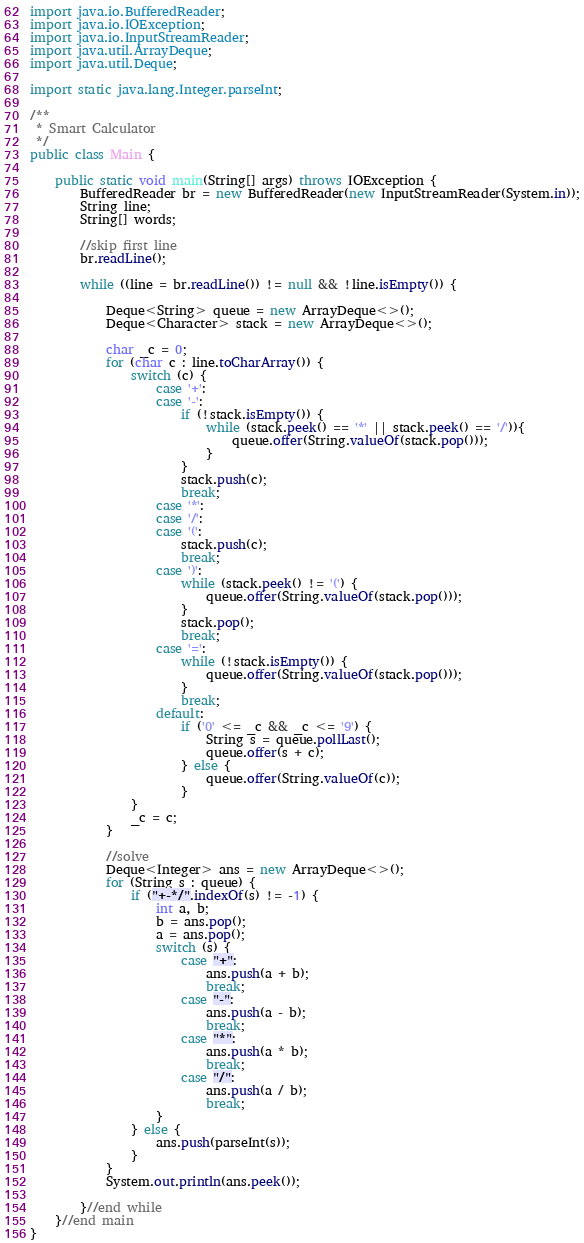<code> <loc_0><loc_0><loc_500><loc_500><_Java_>import java.io.BufferedReader;
import java.io.IOException;
import java.io.InputStreamReader;
import java.util.ArrayDeque;
import java.util.Deque;

import static java.lang.Integer.parseInt;

/**
 * Smart Calculator
 */
public class Main {

	public static void main(String[] args) throws IOException {
		BufferedReader br = new BufferedReader(new InputStreamReader(System.in));
		String line;
		String[] words;

		//skip first line
		br.readLine();

		while ((line = br.readLine()) != null && !line.isEmpty()) {

			Deque<String> queue = new ArrayDeque<>();
			Deque<Character> stack = new ArrayDeque<>();

			char _c = 0;
			for (char c : line.toCharArray()) {
				switch (c) {
					case '+':
					case '-':
						if (!stack.isEmpty()) {
							while (stack.peek() == '*' || stack.peek() == '/')){
								queue.offer(String.valueOf(stack.pop()));
							}
						}
						stack.push(c);
						break;
					case '*':
					case '/':
					case '(':
						stack.push(c);
						break;
					case ')':
						while (stack.peek() != '(') {
							queue.offer(String.valueOf(stack.pop()));
						}
						stack.pop();
						break;
					case '=':
						while (!stack.isEmpty()) {
							queue.offer(String.valueOf(stack.pop()));
						}
						break;
					default:
						if ('0' <= _c && _c <= '9') {
							String s = queue.pollLast();
							queue.offer(s + c);
						} else {
							queue.offer(String.valueOf(c));
						}
				}
				_c = c;
			}

			//solve
			Deque<Integer> ans = new ArrayDeque<>();
			for (String s : queue) {
				if ("+-*/".indexOf(s) != -1) {
					int a, b;
					b = ans.pop();
					a = ans.pop();
					switch (s) {
						case "+":
							ans.push(a + b);
							break;
						case "-":
							ans.push(a - b);
							break;
						case "*":
							ans.push(a * b);
							break;
						case "/":
							ans.push(a / b);
							break;
					}
				} else {
					ans.push(parseInt(s));
				}
			}
			System.out.println(ans.peek());

		}//end while
	}//end main
}</code> 